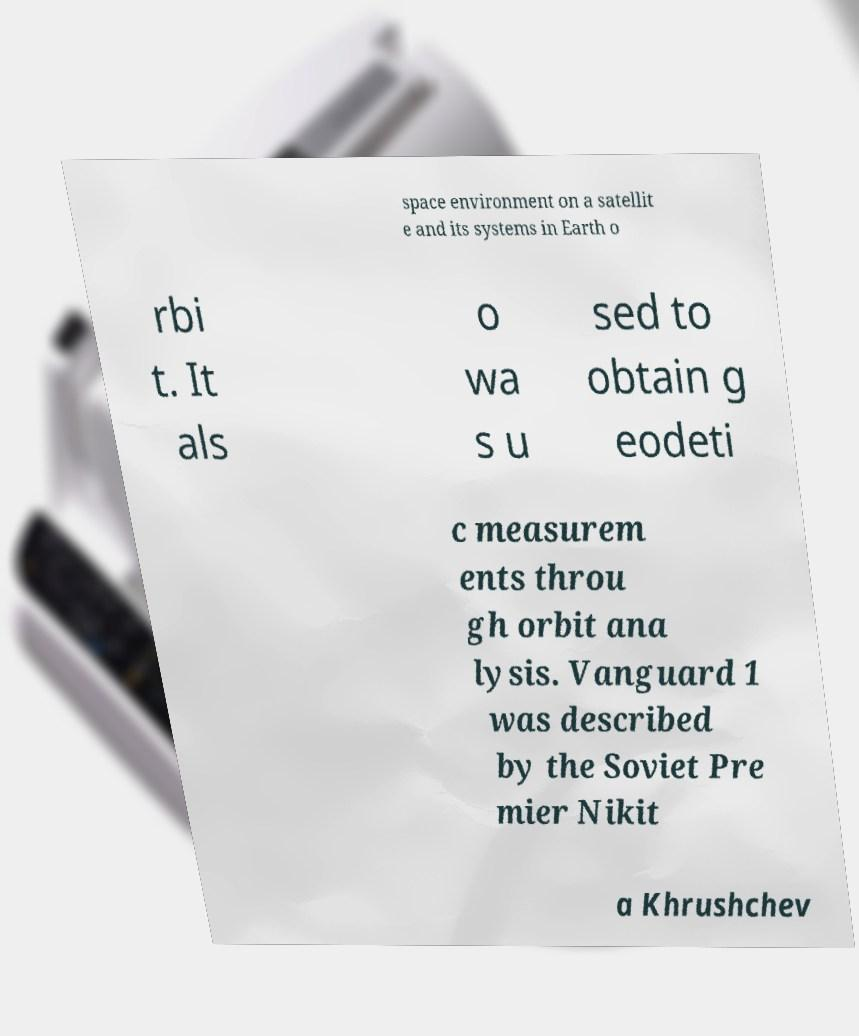Can you accurately transcribe the text from the provided image for me? space environment on a satellit e and its systems in Earth o rbi t. It als o wa s u sed to obtain g eodeti c measurem ents throu gh orbit ana lysis. Vanguard 1 was described by the Soviet Pre mier Nikit a Khrushchev 